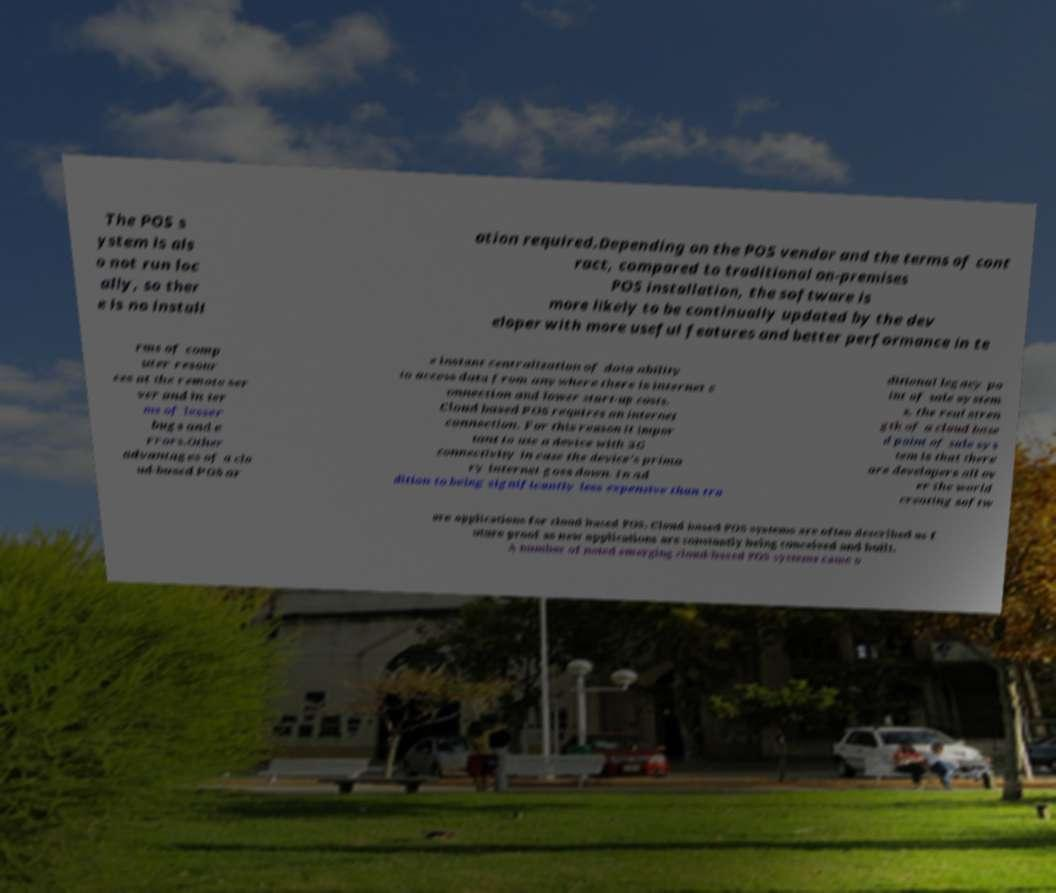For documentation purposes, I need the text within this image transcribed. Could you provide that? The POS s ystem is als o not run loc ally, so ther e is no install ation required.Depending on the POS vendor and the terms of cont ract, compared to traditional on-premises POS installation, the software is more likely to be continually updated by the dev eloper with more useful features and better performance in te rms of comp uter resour ces at the remote ser ver and in ter ms of lesser bugs and e rrors.Other advantages of a clo ud-based POS ar e instant centralization of data ability to access data from anywhere there is internet c onnection and lower start-up costs. Cloud based POS requires an internet connection. For this reason it impor tant to use a device with 3G connectivity in case the device's prima ry internet goes down. In ad dition to being significantly less expensive than tra ditional legacy po int of sale system s, the real stren gth of a cloud base d point of sale sys tem is that there are developers all ov er the world creating softw are applications for cloud based POS. Cloud based POS systems are often described as f uture proof as new applications are constantly being conceived and built. A number of noted emerging cloud-based POS systems came o 